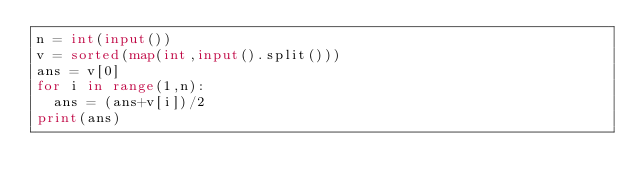<code> <loc_0><loc_0><loc_500><loc_500><_Python_>n = int(input())
v = sorted(map(int,input().split()))
ans = v[0]
for i in range(1,n):
  ans = (ans+v[i])/2
print(ans)</code> 